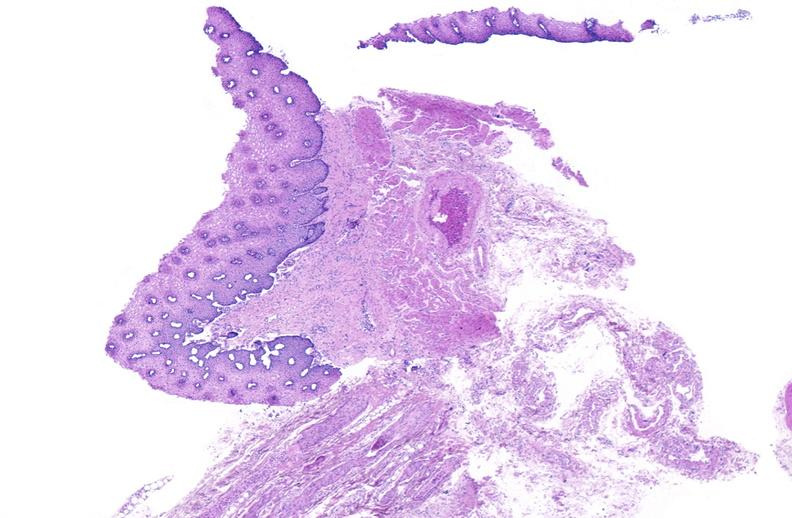what does this image show?
Answer the question using a single word or phrase. Esophagus 